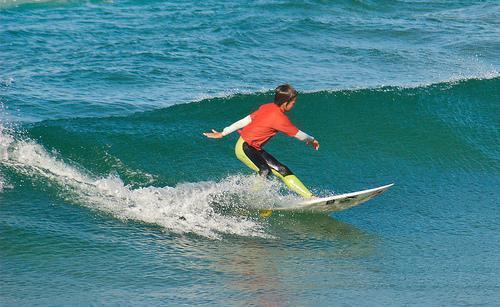How many surfers are there?
Give a very brief answer. 1. 